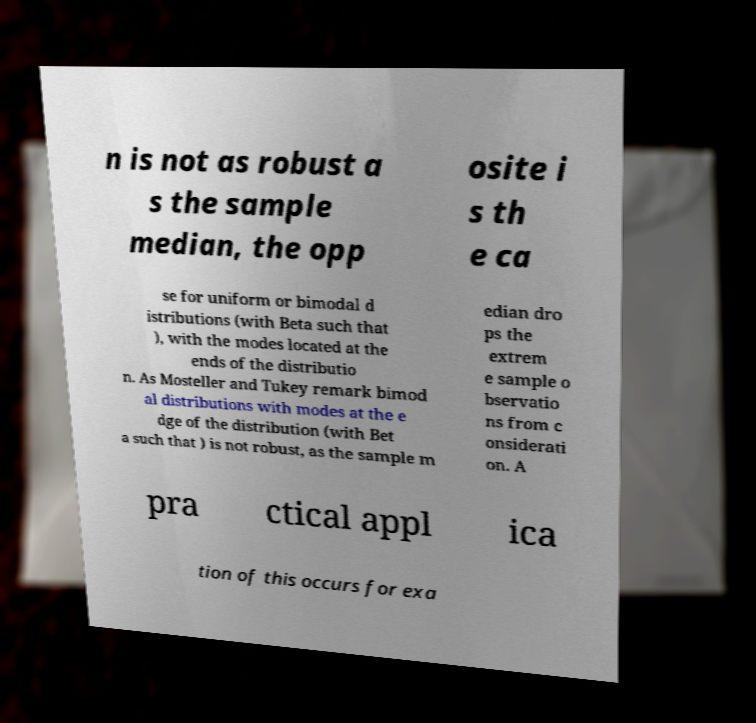What messages or text are displayed in this image? I need them in a readable, typed format. n is not as robust a s the sample median, the opp osite i s th e ca se for uniform or bimodal d istributions (with Beta such that ), with the modes located at the ends of the distributio n. As Mosteller and Tukey remark bimod al distributions with modes at the e dge of the distribution (with Bet a such that ) is not robust, as the sample m edian dro ps the extrem e sample o bservatio ns from c onsiderati on. A pra ctical appl ica tion of this occurs for exa 